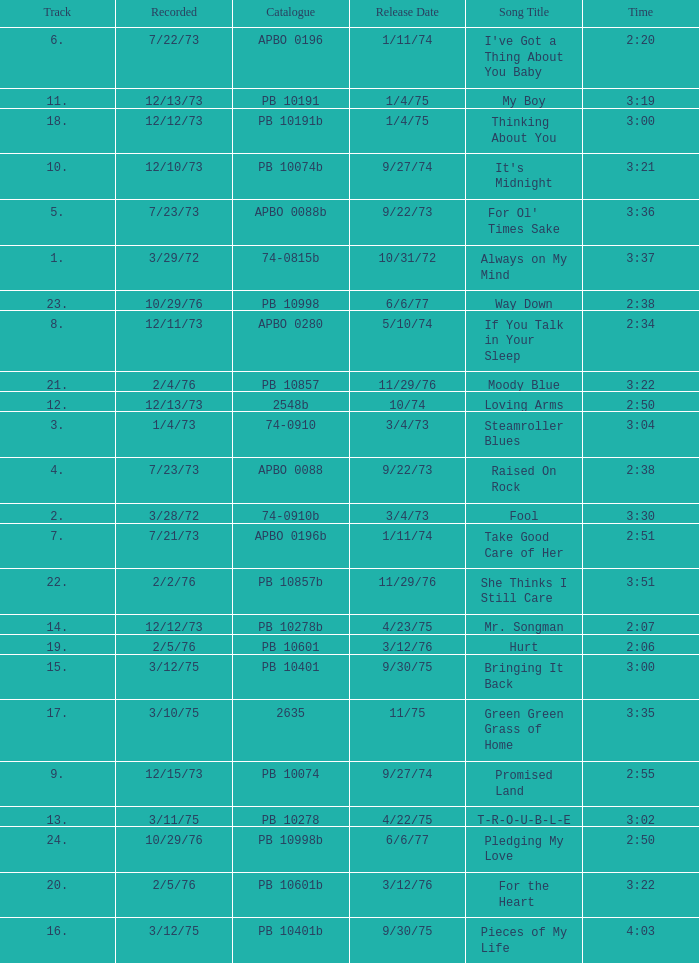Tell me the recorded for time of 2:50 and released date of 6/6/77 with track more than 20 10/29/76. 